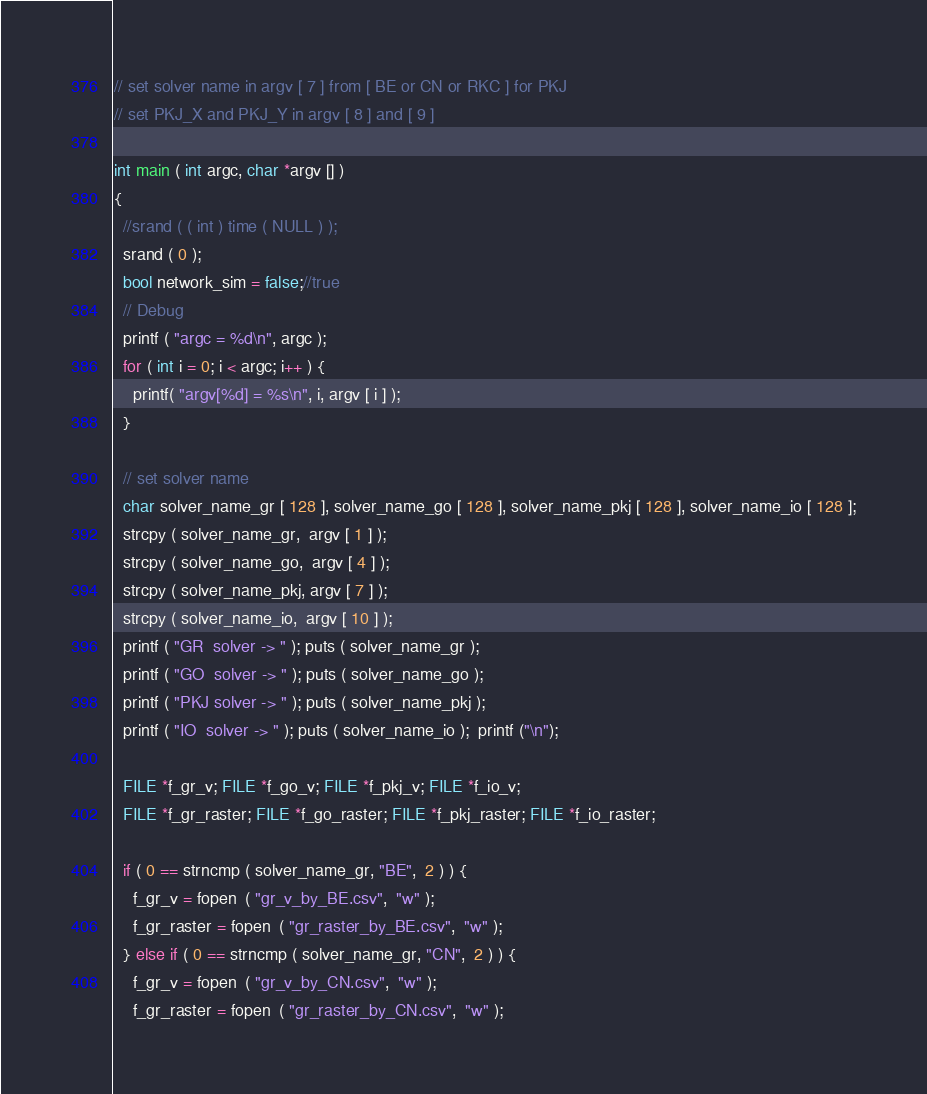Convert code to text. <code><loc_0><loc_0><loc_500><loc_500><_Cuda_>
// set solver name in argv [ 7 ] from [ BE or CN or RKC ] for PKJ
// set PKJ_X and PKJ_Y in argv [ 8 ] and [ 9 ] 

int main ( int argc, char *argv [] ) 
{
  //srand ( ( int ) time ( NULL ) );
  srand ( 0 );
  bool network_sim = false;//true
  // Debug
  printf ( "argc = %d\n", argc );
  for ( int i = 0; i < argc; i++ ) {
    printf( "argv[%d] = %s\n", i, argv [ i ] );
  }

  // set solver name 
  char solver_name_gr [ 128 ], solver_name_go [ 128 ], solver_name_pkj [ 128 ], solver_name_io [ 128 ];
  strcpy ( solver_name_gr,  argv [ 1 ] );
  strcpy ( solver_name_go,  argv [ 4 ] );
  strcpy ( solver_name_pkj, argv [ 7 ] );
  strcpy ( solver_name_io,  argv [ 10 ] );
  printf ( "GR  solver -> " ); puts ( solver_name_gr );  
  printf ( "GO  solver -> " ); puts ( solver_name_go );  
  printf ( "PKJ solver -> " ); puts ( solver_name_pkj ); 
  printf ( "IO  solver -> " ); puts ( solver_name_io );  printf ("\n");

  FILE *f_gr_v; FILE *f_go_v; FILE *f_pkj_v; FILE *f_io_v; 
  FILE *f_gr_raster; FILE *f_go_raster; FILE *f_pkj_raster; FILE *f_io_raster; 

  if ( 0 == strncmp ( solver_name_gr, "BE",  2 ) ) {
    f_gr_v = fopen  ( "gr_v_by_BE.csv",  "w" );  
    f_gr_raster = fopen  ( "gr_raster_by_BE.csv",  "w" );  
  } else if ( 0 == strncmp ( solver_name_gr, "CN",  2 ) ) {
    f_gr_v = fopen  ( "gr_v_by_CN.csv",  "w" );  
    f_gr_raster = fopen  ( "gr_raster_by_CN.csv",  "w" );  </code> 